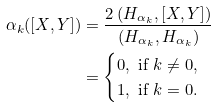<formula> <loc_0><loc_0><loc_500><loc_500>\alpha _ { k } ( [ X , Y ] ) & = \frac { 2 \left ( H _ { \alpha _ { k } } , [ X , Y ] \right ) } { ( H _ { \alpha _ { k } } , H _ { \alpha _ { k } } ) } \\ & = \begin{cases} 0 , \text { if } k \neq 0 , \\ 1 , \text { if } k = 0 . \end{cases}</formula> 